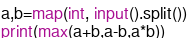<code> <loc_0><loc_0><loc_500><loc_500><_Python_>a,b=map(int, input().split())
print(max(a+b,a-b,a*b))</code> 